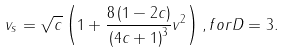<formula> <loc_0><loc_0><loc_500><loc_500>v _ { s } = \sqrt { c } \left ( 1 + \frac { 8 \left ( 1 - 2 c \right ) } { \left ( 4 c + 1 \right ) ^ { 3 } } v ^ { 2 } \right ) , f o r D = 3 .</formula> 